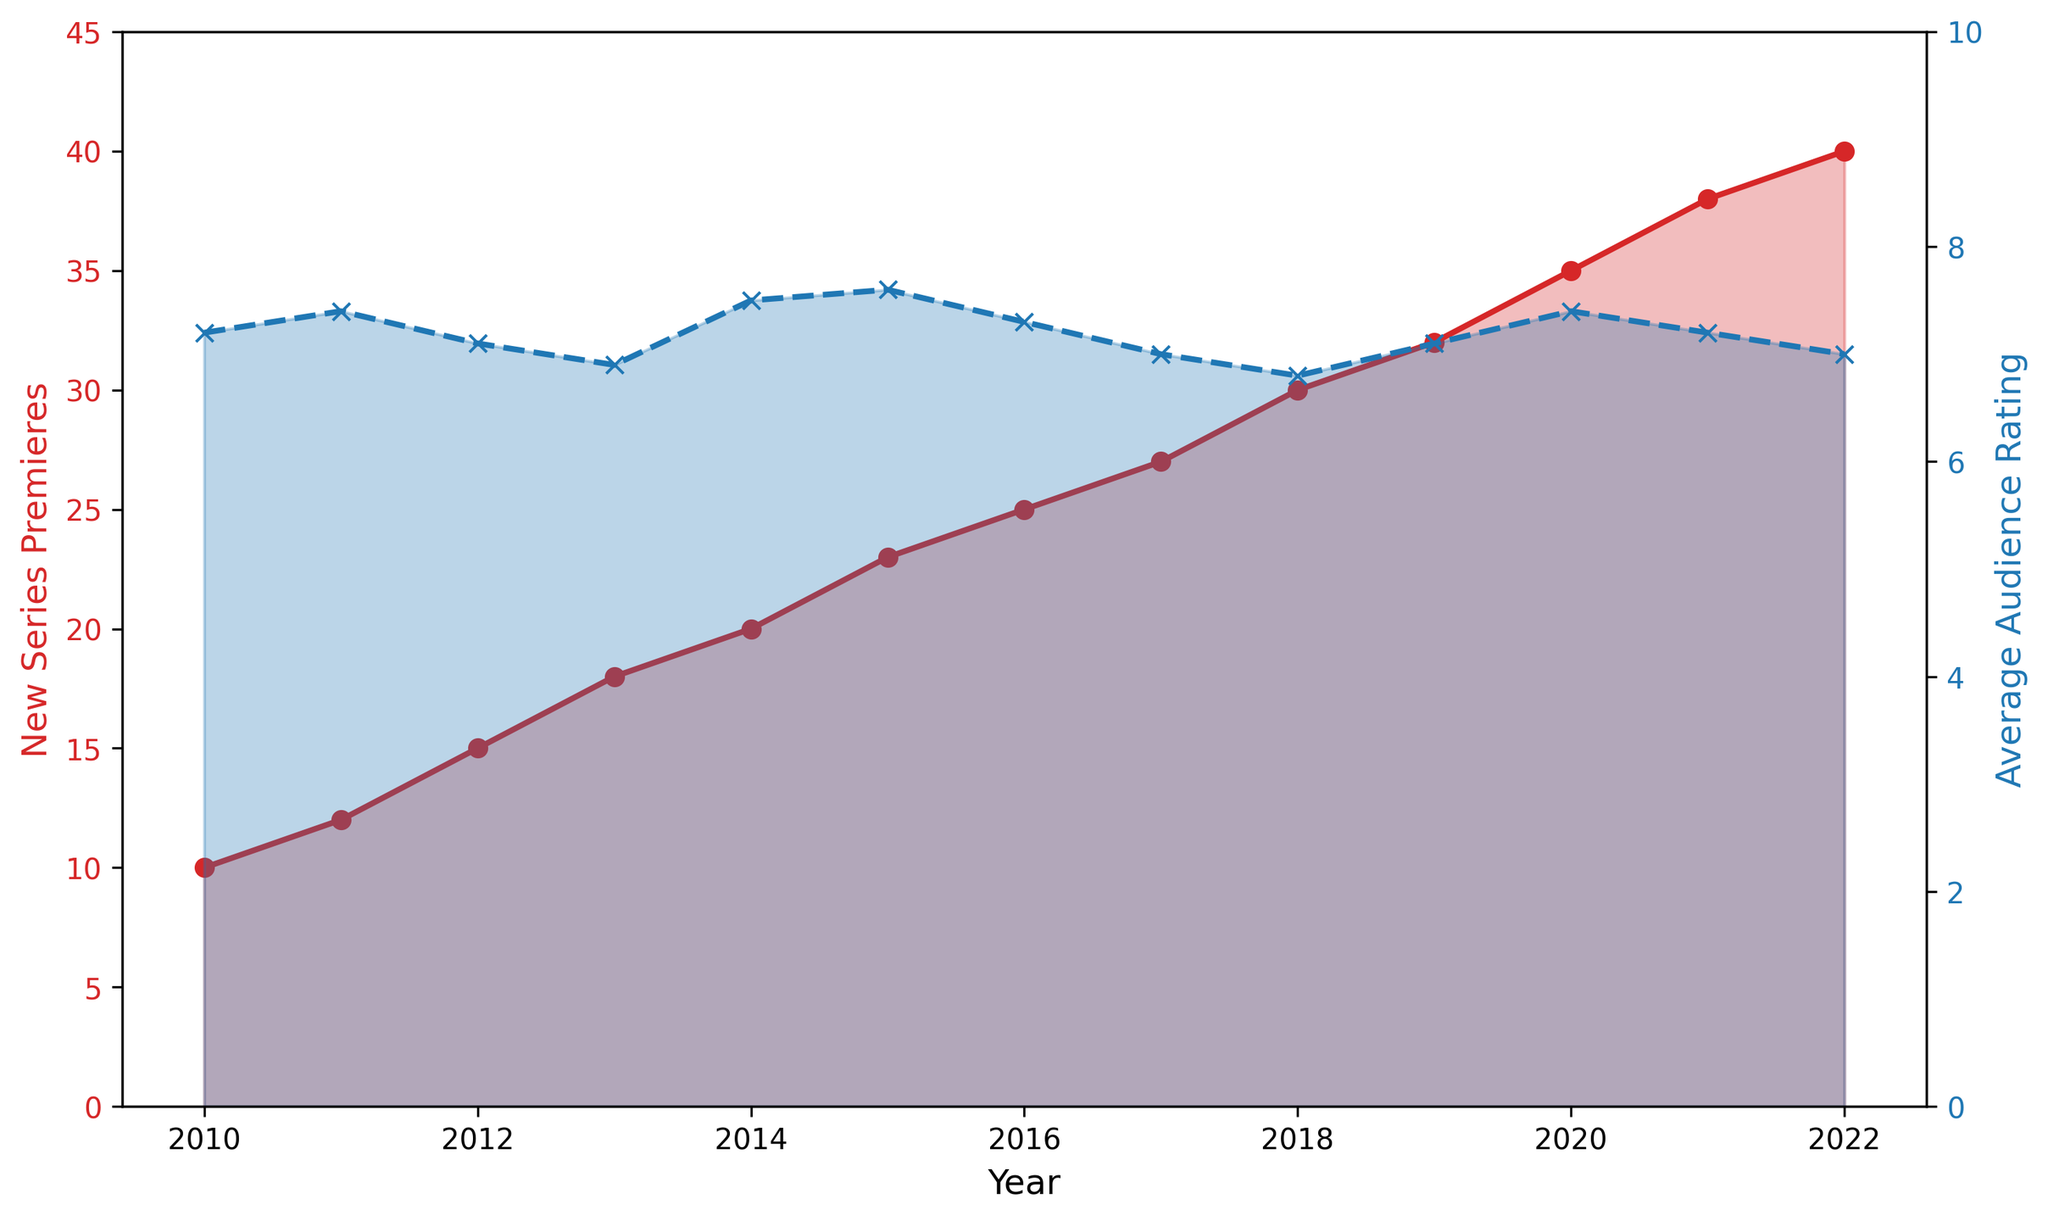How did the number of new series premieres change from 2010 to 2022? In 2010, the number of new series premieres was 10, and in 2022, it was 40. The change can be calculated by subtracting the earlier value from the later value: 40 - 10 = 30.
Answer: Increased by 30 What was the highest average audience rating reported, and in which year did it occur? The highest average audience rating is indicated by the peak on the blue line. The highest rating is 7.6, which occurred in 2015.
Answer: 7.6 in 2015 How many more new series premiered in 2018 compared to 2014? The number of new series in 2018 was 30, and in 2014, it was 20. The difference is 30 - 20 = 10.
Answer: 10 more Compare the average audience rating in 2013 with that of 2017. Which year had a higher rating, and by how much? The average audience rating in 2013 was 6.9, and in 2017 it was 7.0. 2017 had a higher rating by 7.0 - 6.9 = 0.1.
Answer: 2017 by 0.1 What is the trend in the number of new series premieres over the years? The red line representing the number of new series premieres shows a clear upward trend from 2010 to 2022. Each year, the number generally increases, with no years showing a decrease.
Answer: Upward trend Describe the pattern of average audience ratings from 2010 to 2022. The blue line shows average audience ratings initially increase, peaking in 2015, then generally decreasing with some fluctuations from 2016 to 2022.
Answer: Increase then decrease What is the difference in average audience ratings between the highest and lowest years? The highest rating is 7.6 in 2015 and the lowest is 6.8 in 2018. The difference is 7.6 - 6.8 = 0.8.
Answer: 0.8 Which year had the largest increase in new series premieres compared to the previous year? By examining the steepest rise in the red line, the year with the largest increase is from 2019 (32 series) to 2020 (35 series), which is an increase of 3.
Answer: From 2019 to 2020 How does the number of new series in 2020 compare to that in 2012? In 2020, there were 35 new series, and in 2012, there were 15 new series. The difference is 35 - 15 = 20.
Answer: 20 more in 2020 Identify any correlation between the number of new series premieres and the average audience ratings. Generally, as the number of new series increases (red line), the average audience ratings (blue line) do not consistently follow a clear pattern. They increase initially but tend to decrease after reaching a peak, indicating a potential inverse relationship.
Answer: Possible inverse relationship 